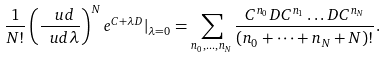<formula> <loc_0><loc_0><loc_500><loc_500>\frac { 1 } { N ! } \left ( \frac { \ u d } { \ u d \lambda } \right ) ^ { N } e ^ { C + \lambda D } | _ { \lambda = 0 } = \sum _ { n _ { 0 } , \dots , n _ { N } } \frac { C ^ { n _ { 0 } } D C ^ { n _ { 1 } } \dots D C ^ { n _ { N } } } { ( n _ { 0 } + \dots + n _ { N } + N ) ! } .</formula> 